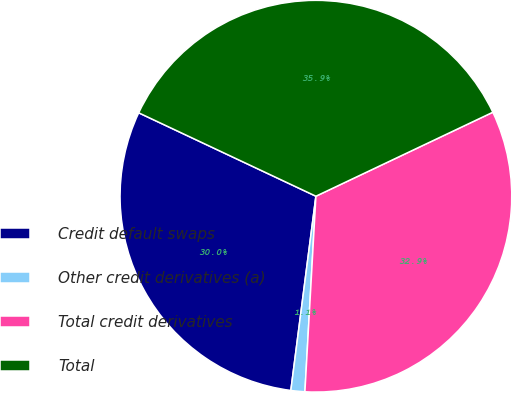Convert chart. <chart><loc_0><loc_0><loc_500><loc_500><pie_chart><fcel>Credit default swaps<fcel>Other credit derivatives (a)<fcel>Total credit derivatives<fcel>Total<nl><fcel>29.96%<fcel>1.15%<fcel>32.95%<fcel>35.95%<nl></chart> 